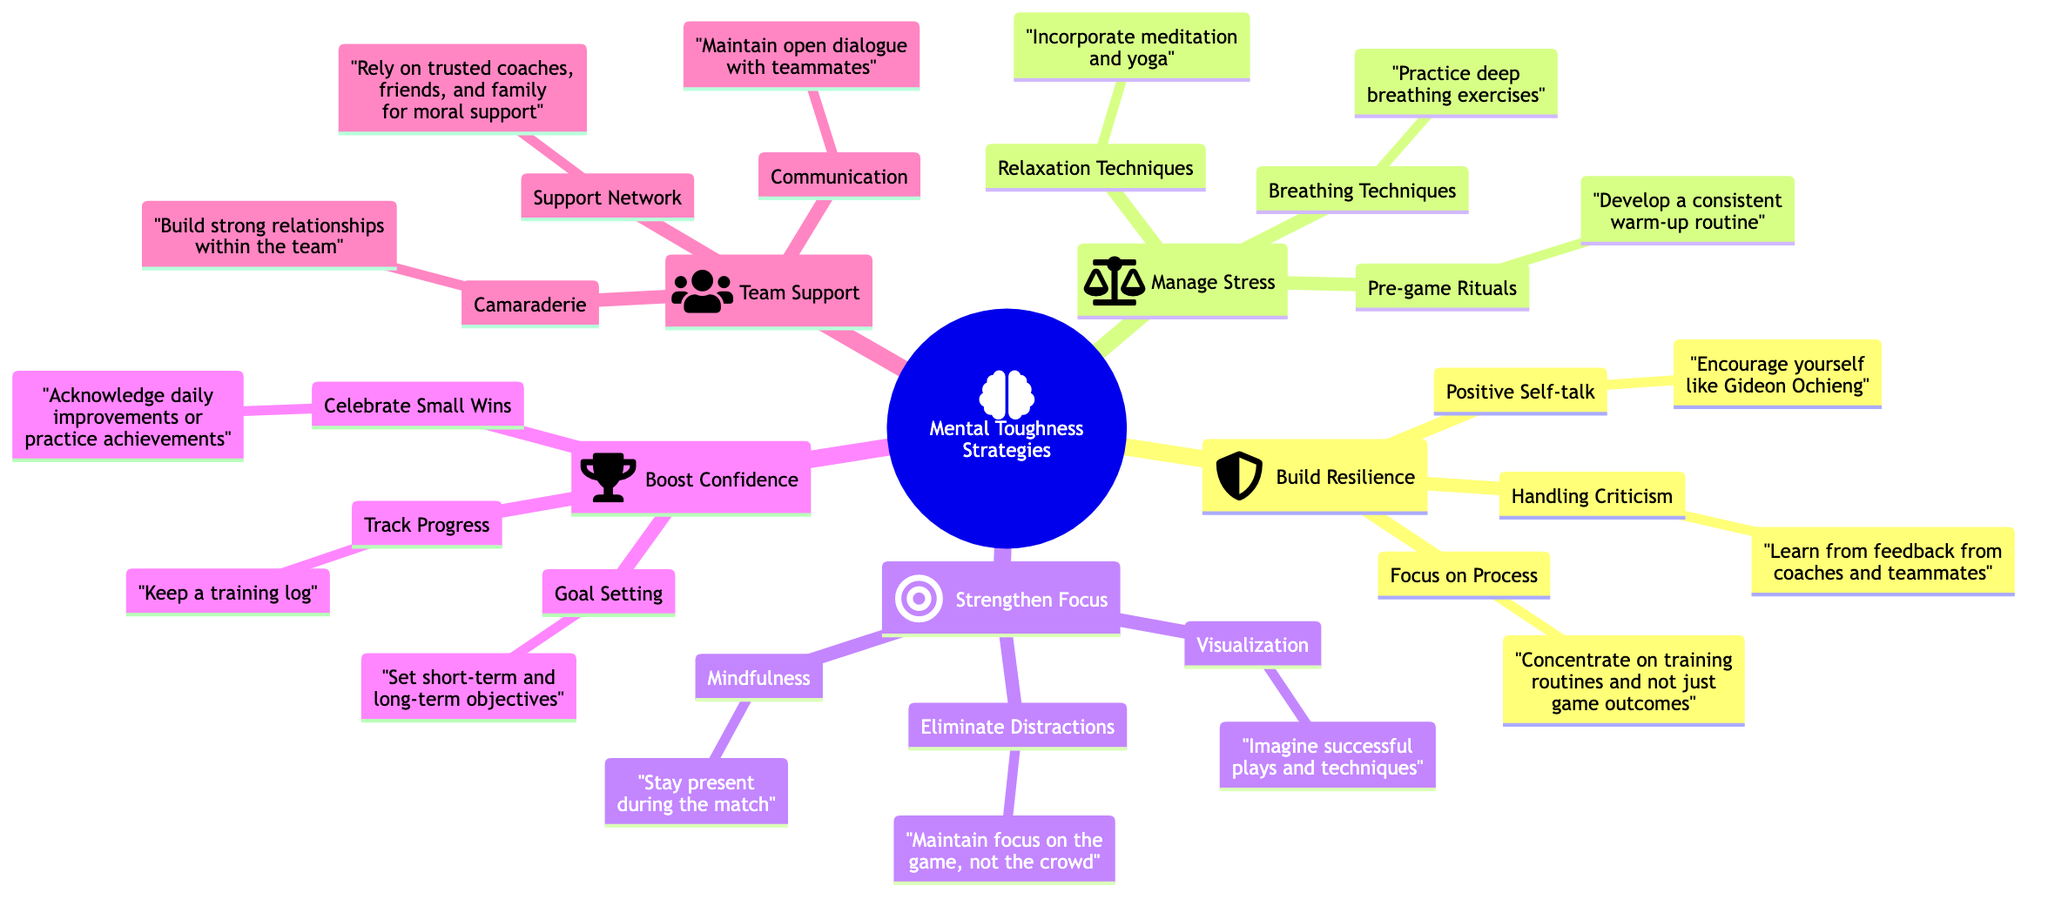What is the main topic of the mind map? The main topic, indicated at the root node, is "Mental Toughness Strategies." This is the central theme around which all other concepts are organized.
Answer: Mental Toughness Strategies How many main strategies are outlined in the diagram? There are five main strategies listed under "Mental Toughness Strategies." Counting them, we see: Build Resilience, Manage Stress, Strengthen Focus, Boost Confidence, and Team Support.
Answer: 5 What sub-element is associated with "Boost Confidence"? The sub-elements under "Boost Confidence" include Goal Setting, Track Progress, and Celebrate Small Wins. Focusing on the first one, "Goal Setting" is directly associated.
Answer: Goal Setting Which strategy includes "Breathing Techniques"? The strategy that includes "Breathing Techniques" is "Manage Stress." This is clearly shown as a sub-element under that strategy.
Answer: Manage Stress How does "Positive Self-talk" relate to the main topic? "Positive Self-talk" is a sub-element of the "Build Resilience" strategy, which is one of the key ways to maintain mental toughness during high-pressure matches, directly supporting the main topic.
Answer: Build Resilience What technique is suggested under "Strengthen Focus"? Under "Strengthen Focus," one suggested technique is "Mindfulness," which advises players to stay present during the match.
Answer: Mindfulness Which sub-element is categorized under "Team Support"? The sub-elements listed under "Team Support" include Communication, Camaraderie, and Support Network. One example is "Camaraderie," which emphasizes building strong relationships within the team.
Answer: Camaraderie What is the relationship between "Celebrate Small Wins" and "Boost Confidence"? "Celebrate Small Wins" is a sub-element under the "Boost Confidence" strategy. This indicates that it is part of the methods to enhance a player's confidence.
Answer: Boost Confidence Which relaxation technique is included under "Manage Stress"? One of the relaxation techniques included under "Manage Stress" is "Incorporate meditation and yoga." This suggests practices to help alleviate stress before matches.
Answer: Incorporate meditation and yoga 